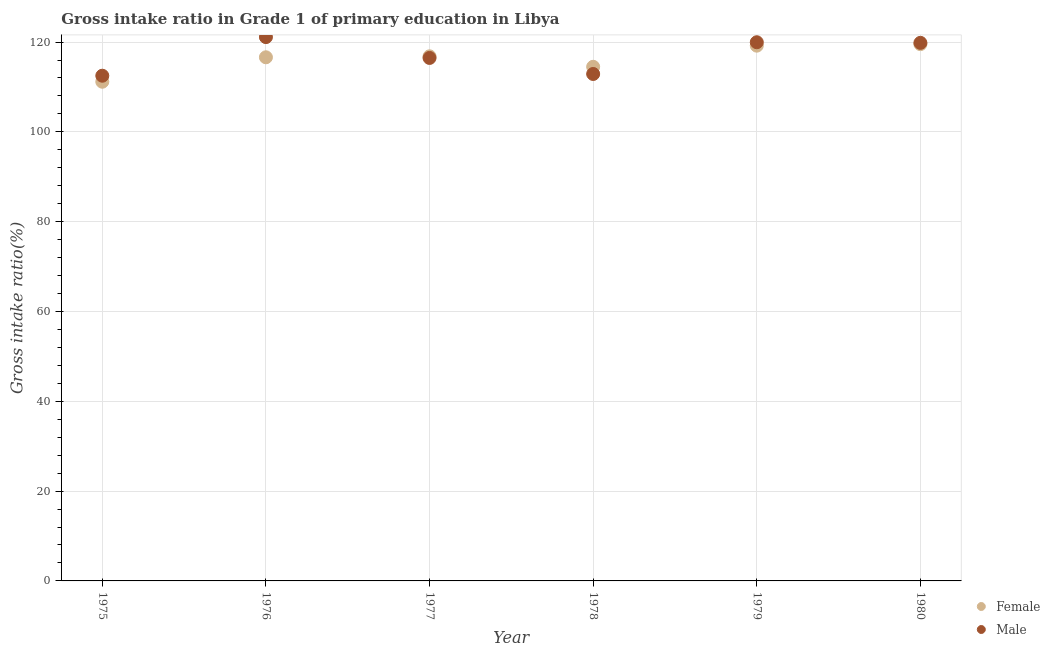How many different coloured dotlines are there?
Provide a short and direct response. 2. What is the gross intake ratio(male) in 1980?
Make the answer very short. 119.82. Across all years, what is the maximum gross intake ratio(female)?
Ensure brevity in your answer.  119.53. Across all years, what is the minimum gross intake ratio(male)?
Provide a succinct answer. 112.5. In which year was the gross intake ratio(male) maximum?
Keep it short and to the point. 1976. In which year was the gross intake ratio(female) minimum?
Offer a terse response. 1975. What is the total gross intake ratio(female) in the graph?
Offer a terse response. 697.8. What is the difference between the gross intake ratio(female) in 1976 and that in 1980?
Offer a terse response. -2.93. What is the difference between the gross intake ratio(female) in 1979 and the gross intake ratio(male) in 1977?
Provide a short and direct response. 2.74. What is the average gross intake ratio(female) per year?
Offer a terse response. 116.3. In the year 1977, what is the difference between the gross intake ratio(female) and gross intake ratio(male)?
Your answer should be compact. 0.36. What is the ratio of the gross intake ratio(male) in 1975 to that in 1980?
Provide a short and direct response. 0.94. Is the difference between the gross intake ratio(male) in 1975 and 1980 greater than the difference between the gross intake ratio(female) in 1975 and 1980?
Offer a terse response. Yes. What is the difference between the highest and the second highest gross intake ratio(female)?
Offer a terse response. 0.34. What is the difference between the highest and the lowest gross intake ratio(male)?
Make the answer very short. 8.6. Does the gross intake ratio(female) monotonically increase over the years?
Provide a succinct answer. No. Is the gross intake ratio(female) strictly less than the gross intake ratio(male) over the years?
Keep it short and to the point. No. How many years are there in the graph?
Keep it short and to the point. 6. Does the graph contain any zero values?
Your response must be concise. No. How are the legend labels stacked?
Make the answer very short. Vertical. What is the title of the graph?
Offer a very short reply. Gross intake ratio in Grade 1 of primary education in Libya. What is the label or title of the X-axis?
Your response must be concise. Year. What is the label or title of the Y-axis?
Your response must be concise. Gross intake ratio(%). What is the Gross intake ratio(%) in Female in 1975?
Your response must be concise. 111.16. What is the Gross intake ratio(%) in Male in 1975?
Your answer should be very brief. 112.5. What is the Gross intake ratio(%) of Female in 1976?
Offer a very short reply. 116.61. What is the Gross intake ratio(%) of Male in 1976?
Your answer should be very brief. 121.1. What is the Gross intake ratio(%) of Female in 1977?
Provide a short and direct response. 116.82. What is the Gross intake ratio(%) of Male in 1977?
Offer a terse response. 116.46. What is the Gross intake ratio(%) in Female in 1978?
Provide a short and direct response. 114.49. What is the Gross intake ratio(%) in Male in 1978?
Ensure brevity in your answer.  112.89. What is the Gross intake ratio(%) of Female in 1979?
Give a very brief answer. 119.19. What is the Gross intake ratio(%) in Male in 1979?
Provide a succinct answer. 119.96. What is the Gross intake ratio(%) of Female in 1980?
Offer a terse response. 119.53. What is the Gross intake ratio(%) in Male in 1980?
Your answer should be compact. 119.82. Across all years, what is the maximum Gross intake ratio(%) in Female?
Offer a terse response. 119.53. Across all years, what is the maximum Gross intake ratio(%) of Male?
Offer a very short reply. 121.1. Across all years, what is the minimum Gross intake ratio(%) of Female?
Make the answer very short. 111.16. Across all years, what is the minimum Gross intake ratio(%) of Male?
Your answer should be very brief. 112.5. What is the total Gross intake ratio(%) in Female in the graph?
Your response must be concise. 697.8. What is the total Gross intake ratio(%) in Male in the graph?
Make the answer very short. 702.72. What is the difference between the Gross intake ratio(%) in Female in 1975 and that in 1976?
Make the answer very short. -5.44. What is the difference between the Gross intake ratio(%) of Male in 1975 and that in 1976?
Give a very brief answer. -8.6. What is the difference between the Gross intake ratio(%) of Female in 1975 and that in 1977?
Offer a very short reply. -5.66. What is the difference between the Gross intake ratio(%) in Male in 1975 and that in 1977?
Your response must be concise. -3.96. What is the difference between the Gross intake ratio(%) in Female in 1975 and that in 1978?
Give a very brief answer. -3.32. What is the difference between the Gross intake ratio(%) in Male in 1975 and that in 1978?
Your answer should be very brief. -0.39. What is the difference between the Gross intake ratio(%) of Female in 1975 and that in 1979?
Your response must be concise. -8.03. What is the difference between the Gross intake ratio(%) of Male in 1975 and that in 1979?
Your answer should be compact. -7.45. What is the difference between the Gross intake ratio(%) of Female in 1975 and that in 1980?
Provide a short and direct response. -8.37. What is the difference between the Gross intake ratio(%) of Male in 1975 and that in 1980?
Your answer should be compact. -7.32. What is the difference between the Gross intake ratio(%) of Female in 1976 and that in 1977?
Your response must be concise. -0.22. What is the difference between the Gross intake ratio(%) in Male in 1976 and that in 1977?
Give a very brief answer. 4.64. What is the difference between the Gross intake ratio(%) in Female in 1976 and that in 1978?
Ensure brevity in your answer.  2.12. What is the difference between the Gross intake ratio(%) of Male in 1976 and that in 1978?
Provide a short and direct response. 8.21. What is the difference between the Gross intake ratio(%) in Female in 1976 and that in 1979?
Offer a very short reply. -2.59. What is the difference between the Gross intake ratio(%) of Male in 1976 and that in 1979?
Give a very brief answer. 1.14. What is the difference between the Gross intake ratio(%) in Female in 1976 and that in 1980?
Keep it short and to the point. -2.93. What is the difference between the Gross intake ratio(%) of Male in 1976 and that in 1980?
Offer a terse response. 1.28. What is the difference between the Gross intake ratio(%) of Female in 1977 and that in 1978?
Give a very brief answer. 2.34. What is the difference between the Gross intake ratio(%) of Male in 1977 and that in 1978?
Provide a short and direct response. 3.57. What is the difference between the Gross intake ratio(%) of Female in 1977 and that in 1979?
Your response must be concise. -2.37. What is the difference between the Gross intake ratio(%) of Male in 1977 and that in 1979?
Your response must be concise. -3.5. What is the difference between the Gross intake ratio(%) in Female in 1977 and that in 1980?
Offer a terse response. -2.71. What is the difference between the Gross intake ratio(%) of Male in 1977 and that in 1980?
Your answer should be very brief. -3.36. What is the difference between the Gross intake ratio(%) of Female in 1978 and that in 1979?
Make the answer very short. -4.71. What is the difference between the Gross intake ratio(%) of Male in 1978 and that in 1979?
Provide a short and direct response. -7.07. What is the difference between the Gross intake ratio(%) of Female in 1978 and that in 1980?
Provide a succinct answer. -5.05. What is the difference between the Gross intake ratio(%) of Male in 1978 and that in 1980?
Your answer should be very brief. -6.93. What is the difference between the Gross intake ratio(%) in Female in 1979 and that in 1980?
Make the answer very short. -0.34. What is the difference between the Gross intake ratio(%) of Male in 1979 and that in 1980?
Offer a very short reply. 0.13. What is the difference between the Gross intake ratio(%) of Female in 1975 and the Gross intake ratio(%) of Male in 1976?
Provide a short and direct response. -9.94. What is the difference between the Gross intake ratio(%) of Female in 1975 and the Gross intake ratio(%) of Male in 1977?
Ensure brevity in your answer.  -5.3. What is the difference between the Gross intake ratio(%) in Female in 1975 and the Gross intake ratio(%) in Male in 1978?
Your response must be concise. -1.73. What is the difference between the Gross intake ratio(%) of Female in 1975 and the Gross intake ratio(%) of Male in 1979?
Make the answer very short. -8.79. What is the difference between the Gross intake ratio(%) of Female in 1975 and the Gross intake ratio(%) of Male in 1980?
Provide a short and direct response. -8.66. What is the difference between the Gross intake ratio(%) in Female in 1976 and the Gross intake ratio(%) in Male in 1977?
Offer a very short reply. 0.15. What is the difference between the Gross intake ratio(%) of Female in 1976 and the Gross intake ratio(%) of Male in 1978?
Your answer should be compact. 3.72. What is the difference between the Gross intake ratio(%) in Female in 1976 and the Gross intake ratio(%) in Male in 1979?
Make the answer very short. -3.35. What is the difference between the Gross intake ratio(%) in Female in 1976 and the Gross intake ratio(%) in Male in 1980?
Your response must be concise. -3.21. What is the difference between the Gross intake ratio(%) of Female in 1977 and the Gross intake ratio(%) of Male in 1978?
Your response must be concise. 3.93. What is the difference between the Gross intake ratio(%) in Female in 1977 and the Gross intake ratio(%) in Male in 1979?
Ensure brevity in your answer.  -3.13. What is the difference between the Gross intake ratio(%) of Female in 1977 and the Gross intake ratio(%) of Male in 1980?
Your answer should be very brief. -3. What is the difference between the Gross intake ratio(%) of Female in 1978 and the Gross intake ratio(%) of Male in 1979?
Make the answer very short. -5.47. What is the difference between the Gross intake ratio(%) of Female in 1978 and the Gross intake ratio(%) of Male in 1980?
Your response must be concise. -5.33. What is the difference between the Gross intake ratio(%) of Female in 1979 and the Gross intake ratio(%) of Male in 1980?
Ensure brevity in your answer.  -0.63. What is the average Gross intake ratio(%) of Female per year?
Keep it short and to the point. 116.3. What is the average Gross intake ratio(%) of Male per year?
Ensure brevity in your answer.  117.12. In the year 1975, what is the difference between the Gross intake ratio(%) of Female and Gross intake ratio(%) of Male?
Your answer should be very brief. -1.34. In the year 1976, what is the difference between the Gross intake ratio(%) in Female and Gross intake ratio(%) in Male?
Offer a terse response. -4.49. In the year 1977, what is the difference between the Gross intake ratio(%) in Female and Gross intake ratio(%) in Male?
Provide a succinct answer. 0.36. In the year 1978, what is the difference between the Gross intake ratio(%) of Female and Gross intake ratio(%) of Male?
Offer a terse response. 1.6. In the year 1979, what is the difference between the Gross intake ratio(%) in Female and Gross intake ratio(%) in Male?
Your answer should be very brief. -0.76. In the year 1980, what is the difference between the Gross intake ratio(%) in Female and Gross intake ratio(%) in Male?
Offer a terse response. -0.29. What is the ratio of the Gross intake ratio(%) in Female in 1975 to that in 1976?
Your response must be concise. 0.95. What is the ratio of the Gross intake ratio(%) of Male in 1975 to that in 1976?
Ensure brevity in your answer.  0.93. What is the ratio of the Gross intake ratio(%) of Female in 1975 to that in 1977?
Give a very brief answer. 0.95. What is the ratio of the Gross intake ratio(%) of Female in 1975 to that in 1978?
Give a very brief answer. 0.97. What is the ratio of the Gross intake ratio(%) of Female in 1975 to that in 1979?
Your answer should be very brief. 0.93. What is the ratio of the Gross intake ratio(%) in Male in 1975 to that in 1979?
Provide a short and direct response. 0.94. What is the ratio of the Gross intake ratio(%) in Female in 1975 to that in 1980?
Give a very brief answer. 0.93. What is the ratio of the Gross intake ratio(%) of Male in 1975 to that in 1980?
Provide a succinct answer. 0.94. What is the ratio of the Gross intake ratio(%) in Male in 1976 to that in 1977?
Offer a terse response. 1.04. What is the ratio of the Gross intake ratio(%) of Female in 1976 to that in 1978?
Ensure brevity in your answer.  1.02. What is the ratio of the Gross intake ratio(%) of Male in 1976 to that in 1978?
Provide a succinct answer. 1.07. What is the ratio of the Gross intake ratio(%) of Female in 1976 to that in 1979?
Make the answer very short. 0.98. What is the ratio of the Gross intake ratio(%) of Male in 1976 to that in 1979?
Make the answer very short. 1.01. What is the ratio of the Gross intake ratio(%) in Female in 1976 to that in 1980?
Keep it short and to the point. 0.98. What is the ratio of the Gross intake ratio(%) in Male in 1976 to that in 1980?
Offer a very short reply. 1.01. What is the ratio of the Gross intake ratio(%) of Female in 1977 to that in 1978?
Provide a succinct answer. 1.02. What is the ratio of the Gross intake ratio(%) of Male in 1977 to that in 1978?
Offer a terse response. 1.03. What is the ratio of the Gross intake ratio(%) of Female in 1977 to that in 1979?
Give a very brief answer. 0.98. What is the ratio of the Gross intake ratio(%) of Male in 1977 to that in 1979?
Ensure brevity in your answer.  0.97. What is the ratio of the Gross intake ratio(%) in Female in 1977 to that in 1980?
Keep it short and to the point. 0.98. What is the ratio of the Gross intake ratio(%) in Male in 1977 to that in 1980?
Give a very brief answer. 0.97. What is the ratio of the Gross intake ratio(%) in Female in 1978 to that in 1979?
Provide a short and direct response. 0.96. What is the ratio of the Gross intake ratio(%) in Male in 1978 to that in 1979?
Offer a very short reply. 0.94. What is the ratio of the Gross intake ratio(%) of Female in 1978 to that in 1980?
Offer a very short reply. 0.96. What is the ratio of the Gross intake ratio(%) in Male in 1978 to that in 1980?
Your answer should be very brief. 0.94. What is the ratio of the Gross intake ratio(%) in Female in 1979 to that in 1980?
Offer a very short reply. 1. What is the difference between the highest and the second highest Gross intake ratio(%) in Female?
Ensure brevity in your answer.  0.34. What is the difference between the highest and the second highest Gross intake ratio(%) of Male?
Your answer should be compact. 1.14. What is the difference between the highest and the lowest Gross intake ratio(%) in Female?
Provide a succinct answer. 8.37. What is the difference between the highest and the lowest Gross intake ratio(%) in Male?
Make the answer very short. 8.6. 